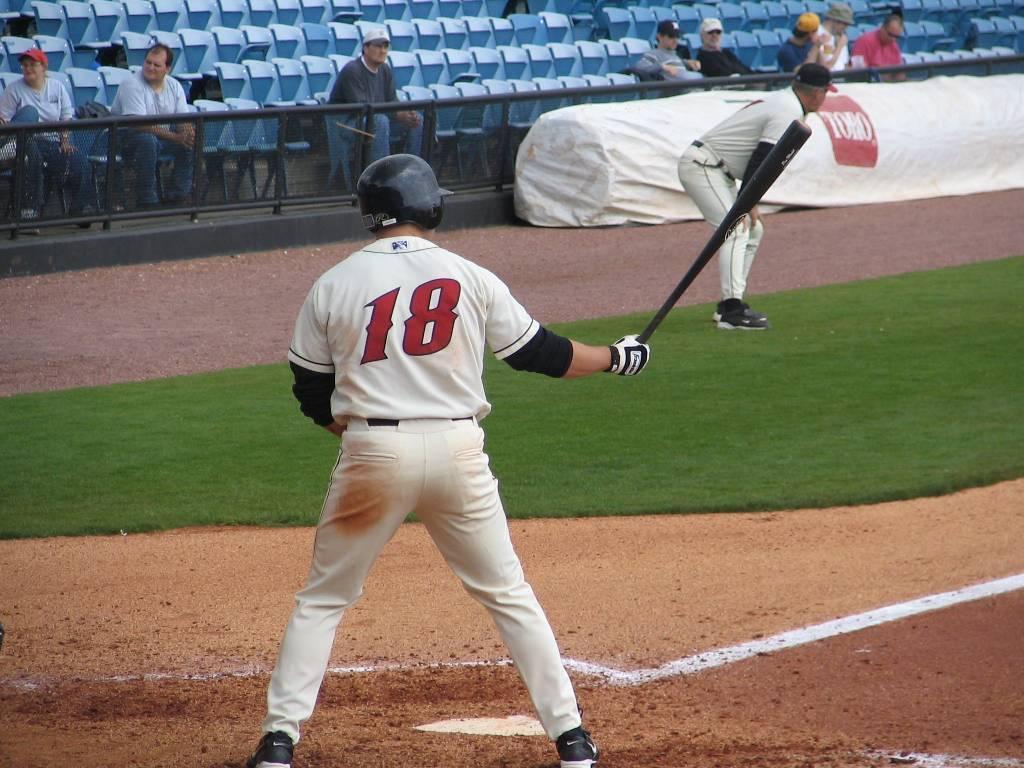In one or two sentences, can you explain what this image depicts? In this image we can see two players are playing baseball. Background of the image sitting area of the stadium is there, were few people are sitting. Right side of the image on land grass is there. 